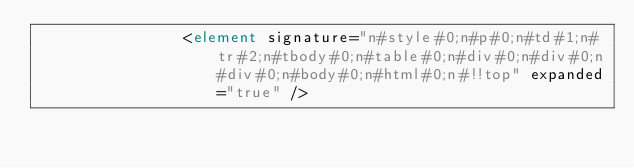Convert code to text. <code><loc_0><loc_0><loc_500><loc_500><_XML_>                <element signature="n#style#0;n#p#0;n#td#1;n#tr#2;n#tbody#0;n#table#0;n#div#0;n#div#0;n#div#0;n#body#0;n#html#0;n#!!top" expanded="true" /></code> 